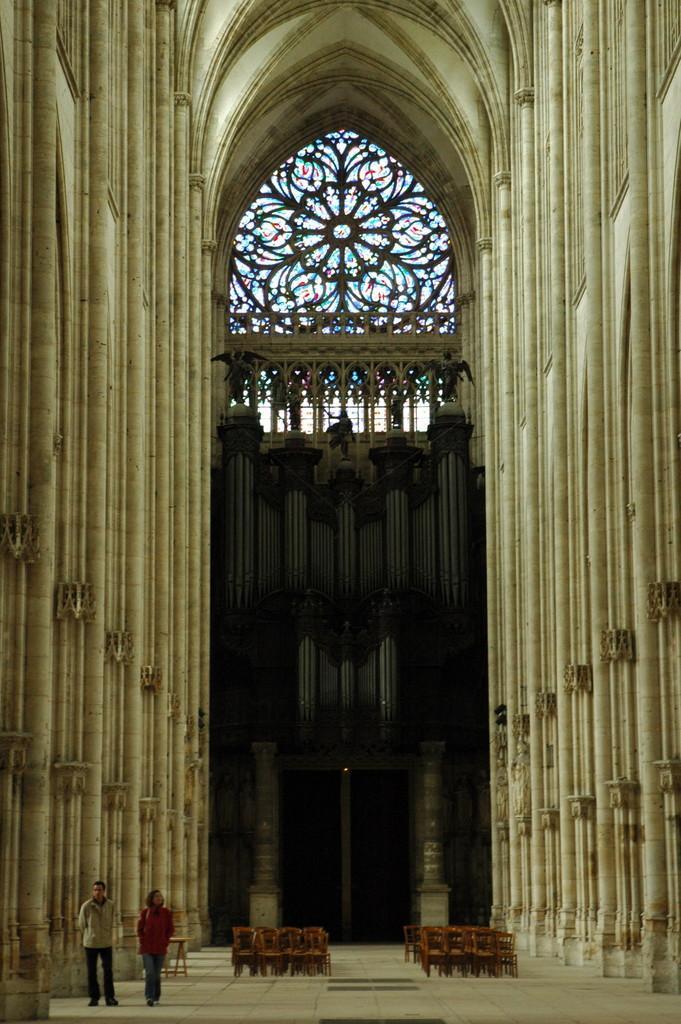Could you give a brief overview of what you see in this image? This image is taken from inside. In this image there are two people standing on the floor, there are a few chairs arranged. In the background there are pillars and windows. 